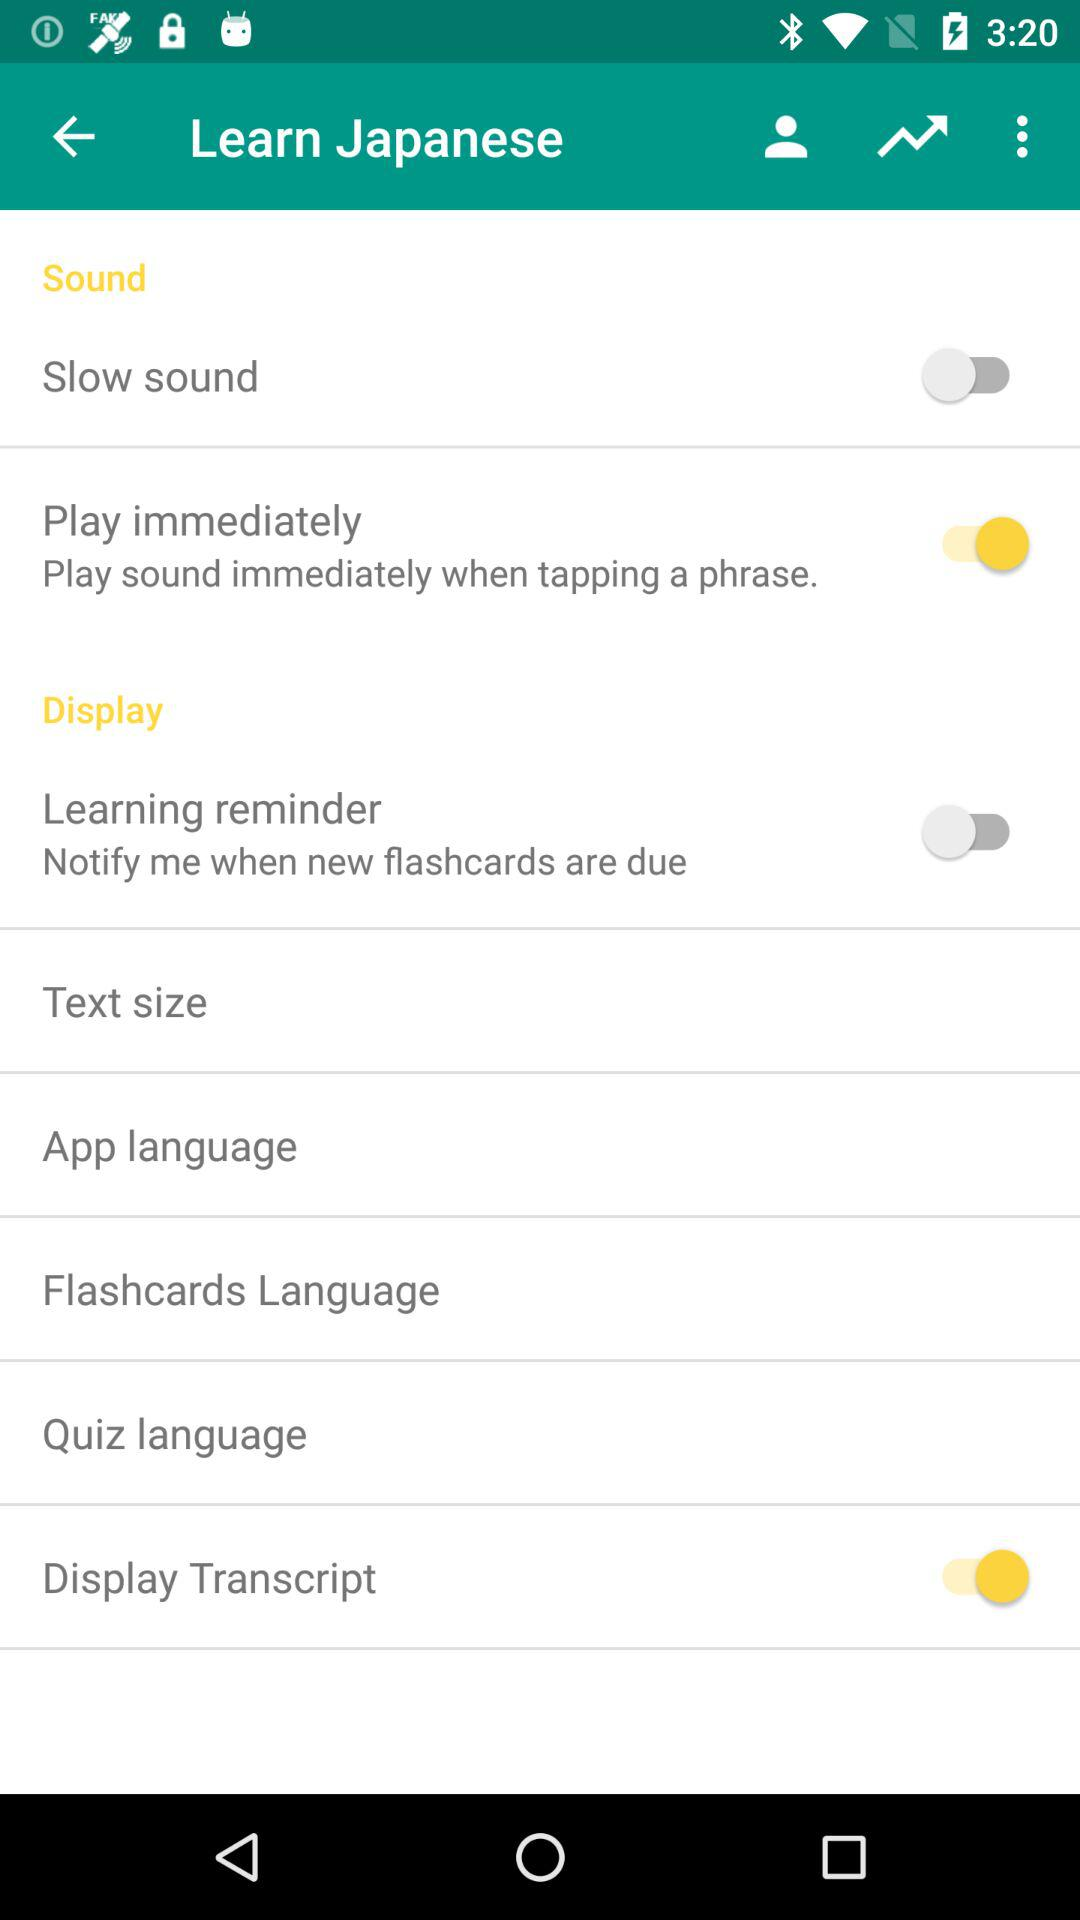What is the status of the "Learning reminder" setting? The status of the "Learning reminder" setting is "off". 